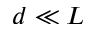<formula> <loc_0><loc_0><loc_500><loc_500>d \ll L</formula> 